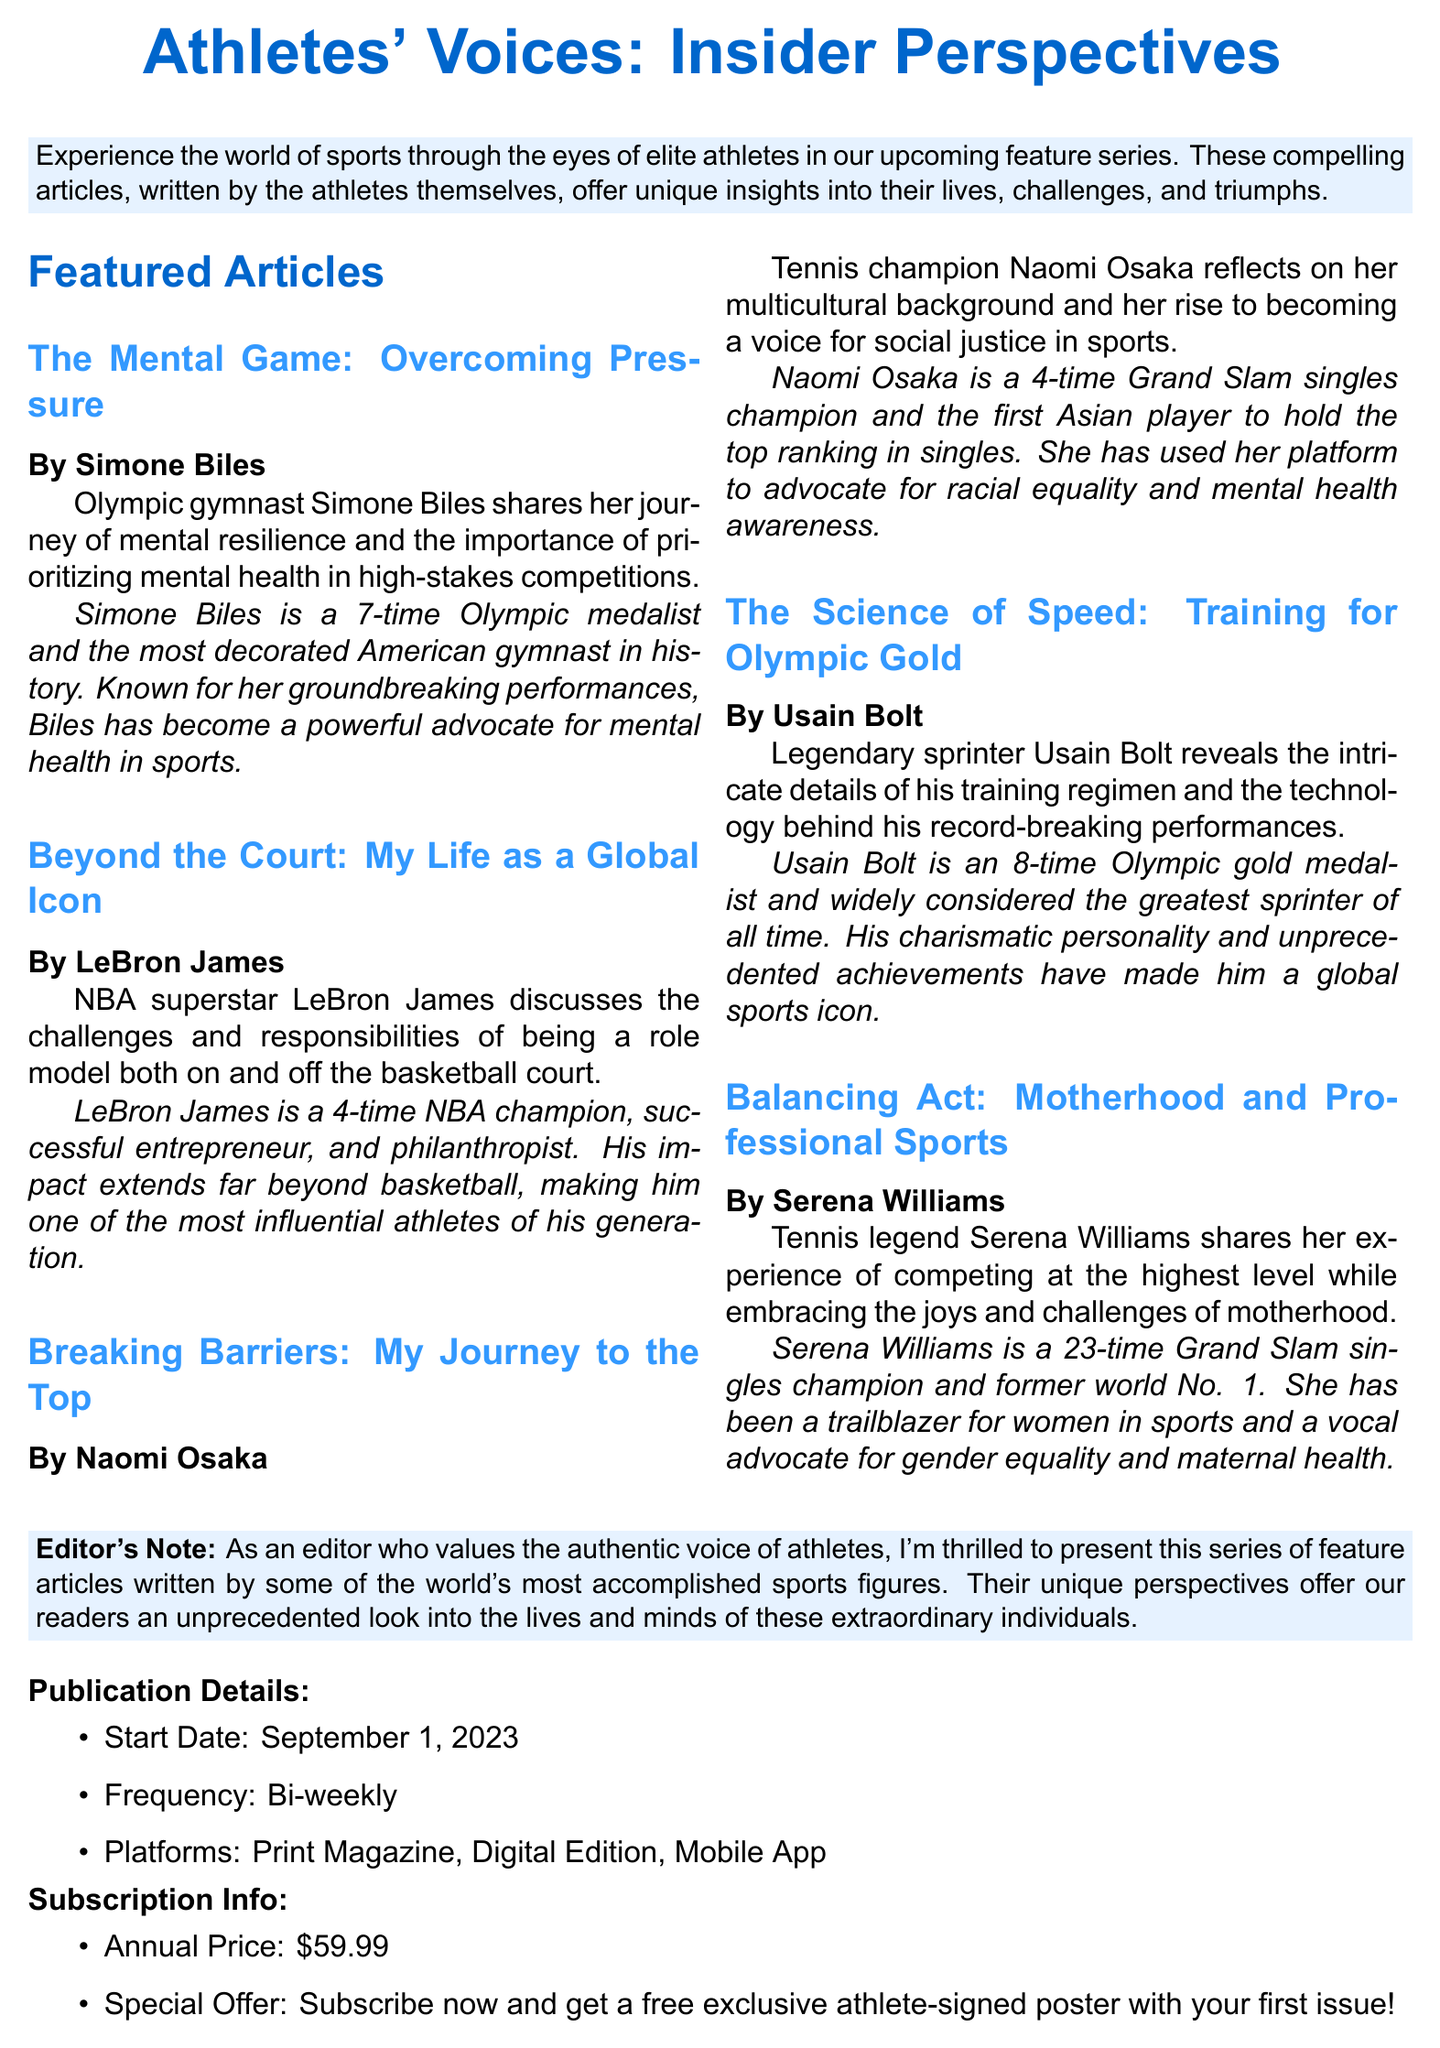What is the title of the brochure? The title of the brochure is found in the header section.
Answer: Athletes' Voices: Insider Perspectives Who wrote the article on mental resilience? The author of the article on mental resilience is listed under the article title.
Answer: Simone Biles What date does the publication start? The start date of the publication is specifically mentioned in the publication details.
Answer: September 1, 2023 How often will the articles be published? The frequency of publication is stated in the publication details.
Answer: Bi-weekly What special offer is included with the subscription? The special offer is provided as an incentive in the subscription information section.
Answer: Free exclusive athlete-signed poster Which athlete discusses challenges of being a role model? The athlete discussing the challenges of being a role model is mentioned in the featured articles list.
Answer: LeBron James How many times has Serena Williams won the Grand Slam singles championship? The number of times Serena Williams won is included in her author bio.
Answer: 23 times What type of media platforms will feature the articles? The platforms for media distribution are provided under the publication details.
Answer: Print Magazine, Digital Edition, Mobile App What is Naomi Osaka known for in her article? The unique aspect Naomi Osaka focuses on in her article is highlighted in her teaser.
Answer: Social justice in sports 